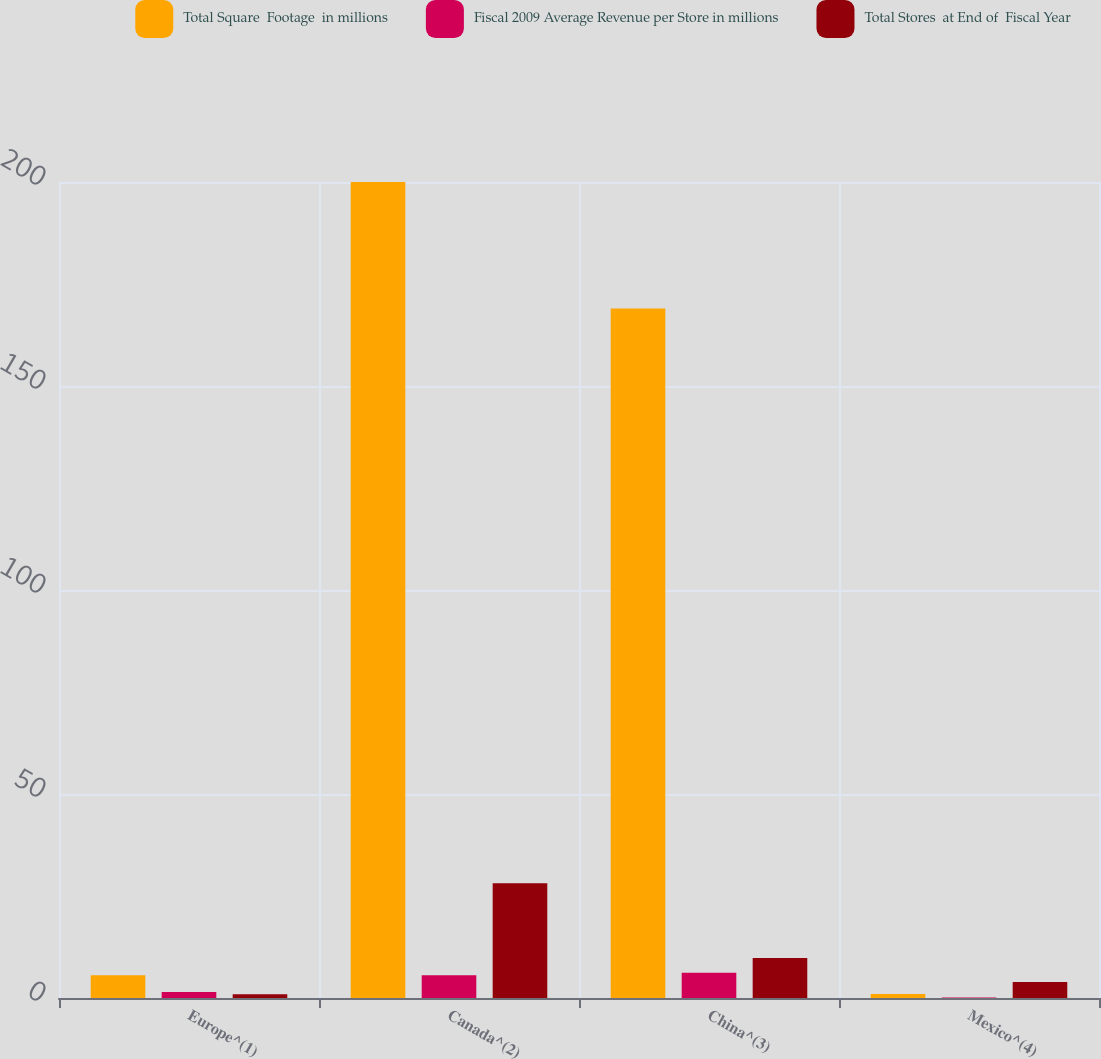Convert chart. <chart><loc_0><loc_0><loc_500><loc_500><stacked_bar_chart><ecel><fcel>Europe^(1)<fcel>Canada^(2)<fcel>China^(3)<fcel>Mexico^(4)<nl><fcel>Total Square  Footage  in millions<fcel>5.6<fcel>200<fcel>169<fcel>1<nl><fcel>Fiscal 2009 Average Revenue per Store in millions<fcel>1.5<fcel>5.6<fcel>6.2<fcel>0.1<nl><fcel>Total Stores  at End of  Fiscal Year<fcel>0.9<fcel>28.1<fcel>9.8<fcel>3.9<nl></chart> 